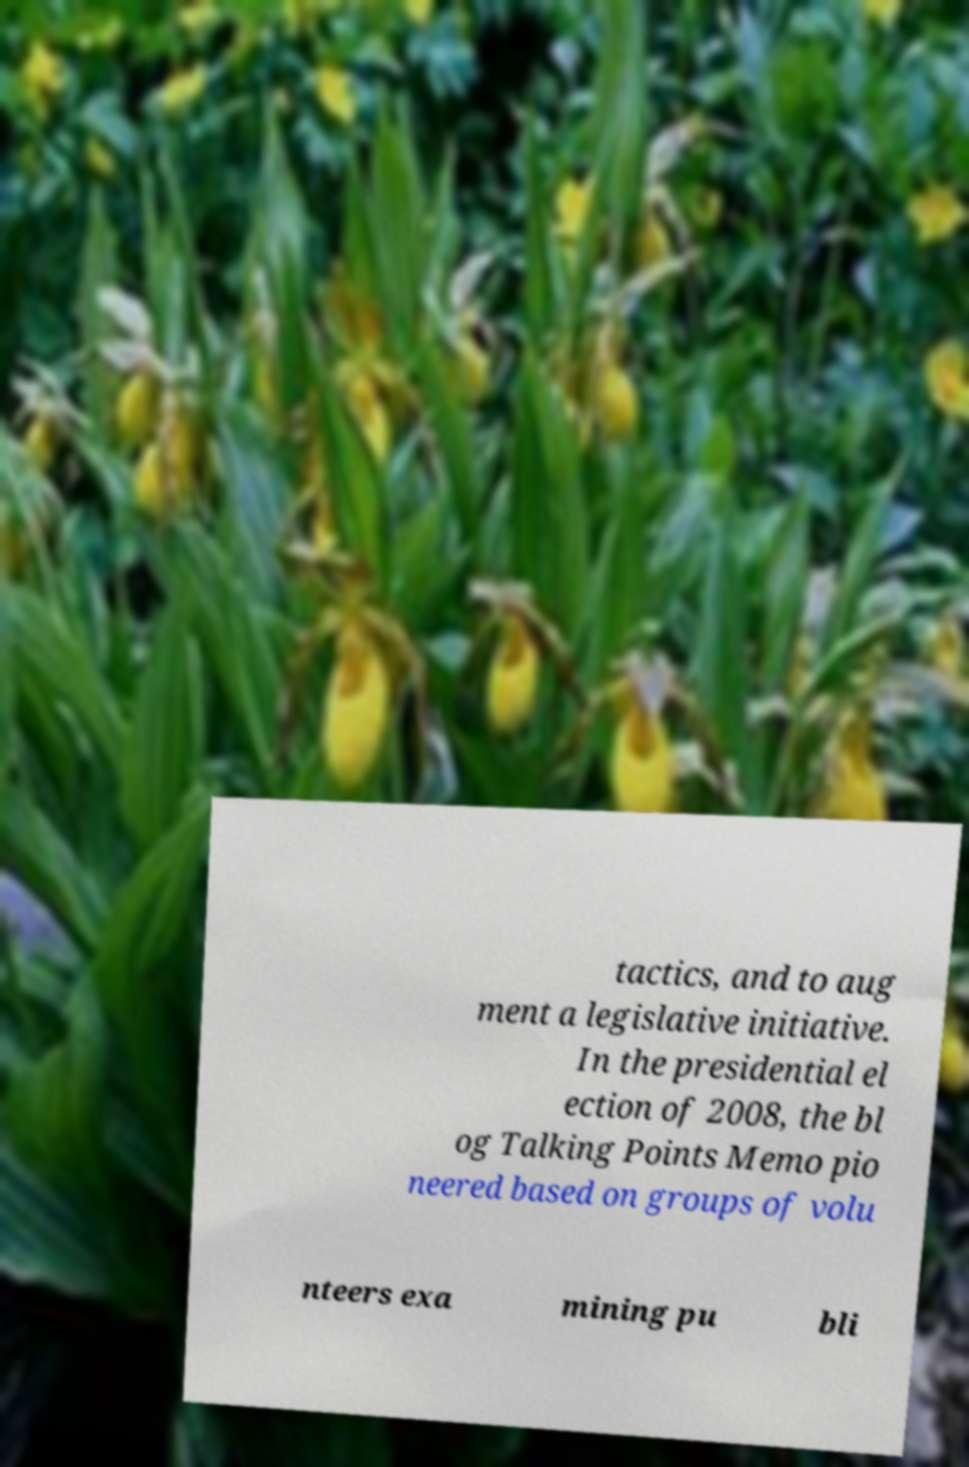I need the written content from this picture converted into text. Can you do that? tactics, and to aug ment a legislative initiative. In the presidential el ection of 2008, the bl og Talking Points Memo pio neered based on groups of volu nteers exa mining pu bli 